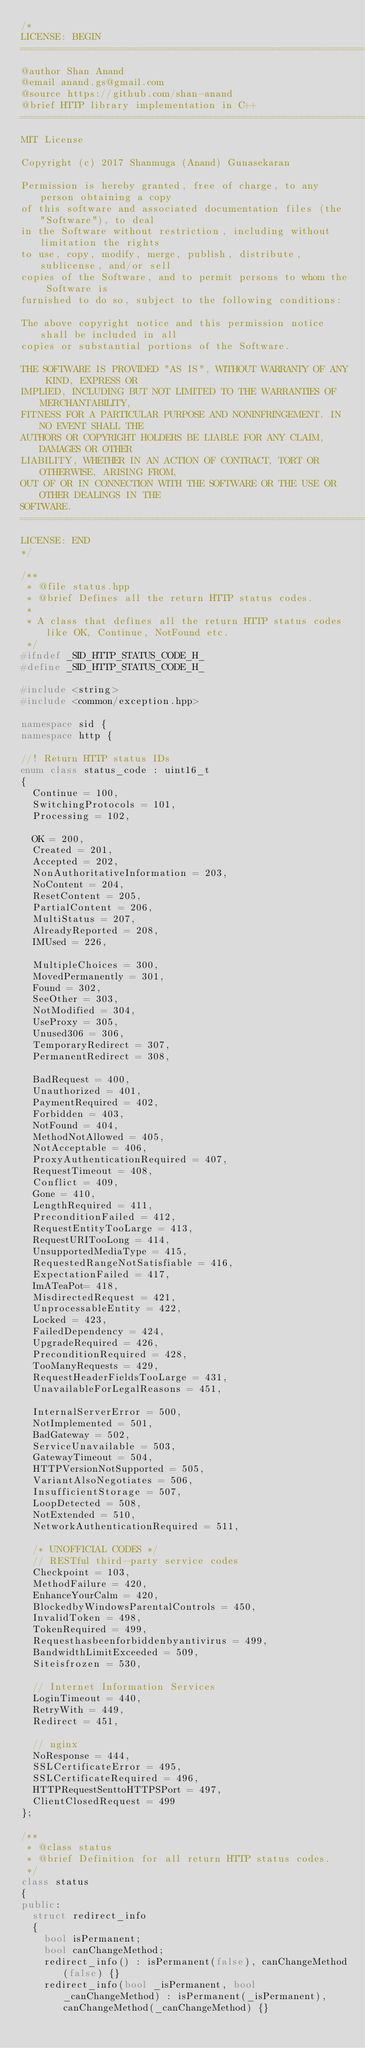<code> <loc_0><loc_0><loc_500><loc_500><_C++_>/*
LICENSE: BEGIN
===============================================================================
@author Shan Anand
@email anand.gs@gmail.com
@source https://github.com/shan-anand
@brief HTTP library implementation in C++
===============================================================================
MIT License

Copyright (c) 2017 Shanmuga (Anand) Gunasekaran

Permission is hereby granted, free of charge, to any person obtaining a copy
of this software and associated documentation files (the "Software"), to deal
in the Software without restriction, including without limitation the rights
to use, copy, modify, merge, publish, distribute, sublicense, and/or sell
copies of the Software, and to permit persons to whom the Software is
furnished to do so, subject to the following conditions:

The above copyright notice and this permission notice shall be included in all
copies or substantial portions of the Software.

THE SOFTWARE IS PROVIDED "AS IS", WITHOUT WARRANTY OF ANY KIND, EXPRESS OR
IMPLIED, INCLUDING BUT NOT LIMITED TO THE WARRANTIES OF MERCHANTABILITY,
FITNESS FOR A PARTICULAR PURPOSE AND NONINFRINGEMENT. IN NO EVENT SHALL THE
AUTHORS OR COPYRIGHT HOLDERS BE LIABLE FOR ANY CLAIM, DAMAGES OR OTHER
LIABILITY, WHETHER IN AN ACTION OF CONTRACT, TORT OR OTHERWISE, ARISING FROM,
OUT OF OR IN CONNECTION WITH THE SOFTWARE OR THE USE OR OTHER DEALINGS IN THE
SOFTWARE.
===============================================================================
LICENSE: END
*/

/**
 * @file status.hpp
 * @brief Defines all the return HTTP status codes.
 *
 * A class that defines all the return HTTP status codes like OK, Continue, NotFound etc.
 */
#ifndef _SID_HTTP_STATUS_CODE_H_
#define _SID_HTTP_STATUS_CODE_H_

#include <string>
#include <common/exception.hpp>

namespace sid {
namespace http {

//! Return HTTP status IDs
enum class status_code : uint16_t
{
  Continue = 100,
  SwitchingProtocols = 101,
  Processing = 102,

  OK = 200,
  Created = 201,
  Accepted = 202,
  NonAuthoritativeInformation = 203,
  NoContent = 204,
  ResetContent = 205,
  PartialContent = 206,
  MultiStatus = 207,
  AlreadyReported = 208,
  IMUsed = 226,

  MultipleChoices = 300,
  MovedPermanently = 301,
  Found = 302,
  SeeOther = 303,
  NotModified = 304,
  UseProxy = 305,
  Unused306 = 306,
  TemporaryRedirect = 307,
  PermanentRedirect = 308,

  BadRequest = 400,
  Unauthorized = 401,
  PaymentRequired = 402,
  Forbidden = 403,
  NotFound = 404,
  MethodNotAllowed = 405,
  NotAcceptable = 406,
  ProxyAuthenticationRequired = 407,
  RequestTimeout = 408,
  Conflict = 409,
  Gone = 410,
  LengthRequired = 411,
  PreconditionFailed = 412,
  RequestEntityTooLarge = 413,
  RequestURITooLong = 414,
  UnsupportedMediaType = 415,
  RequestedRangeNotSatisfiable = 416,
  ExpectationFailed = 417,
  ImATeaPot= 418,
  MisdirectedRequest = 421,
  UnprocessableEntity = 422,
  Locked = 423,
  FailedDependency = 424,
  UpgradeRequired = 426,
  PreconditionRequired = 428,
  TooManyRequests = 429,
  RequestHeaderFieldsTooLarge = 431,
  UnavailableForLegalReasons = 451,

  InternalServerError = 500,
  NotImplemented = 501,
  BadGateway = 502,
  ServiceUnavailable = 503,
  GatewayTimeout = 504,
  HTTPVersionNotSupported = 505,
  VariantAlsoNegotiates = 506,
  InsufficientStorage = 507,
  LoopDetected = 508,
  NotExtended = 510,
  NetworkAuthenticationRequired = 511,

  /* UNOFFICIAL CODES */
  // RESTful third-party service codes
  Checkpoint = 103,
  MethodFailure = 420,
  EnhanceYourCalm = 420,
  BlockedbyWindowsParentalControls = 450,
  InvalidToken = 498,
  TokenRequired = 499,
  Requesthasbeenforbiddenbyantivirus = 499,
  BandwidthLimitExceeded = 509,
  Siteisfrozen = 530,

  // Internet Information Services
  LoginTimeout = 440,
  RetryWith = 449,
  Redirect = 451,

  // nginx
  NoResponse = 444,
  SSLCertificateError = 495,
  SSLCertificateRequired = 496,
  HTTPRequestSenttoHTTPSPort = 497,
  ClientClosedRequest = 499
};

/**
 * @class status
 * @brief Definition for all return HTTP status codes.
 */
class status
{
public:
  struct redirect_info
  {
    bool isPermanent;
    bool canChangeMethod;
    redirect_info() : isPermanent(false), canChangeMethod(false) {}
    redirect_info(bool _isPermanent, bool _canChangeMethod) : isPermanent(_isPermanent), canChangeMethod(_canChangeMethod) {}</code> 